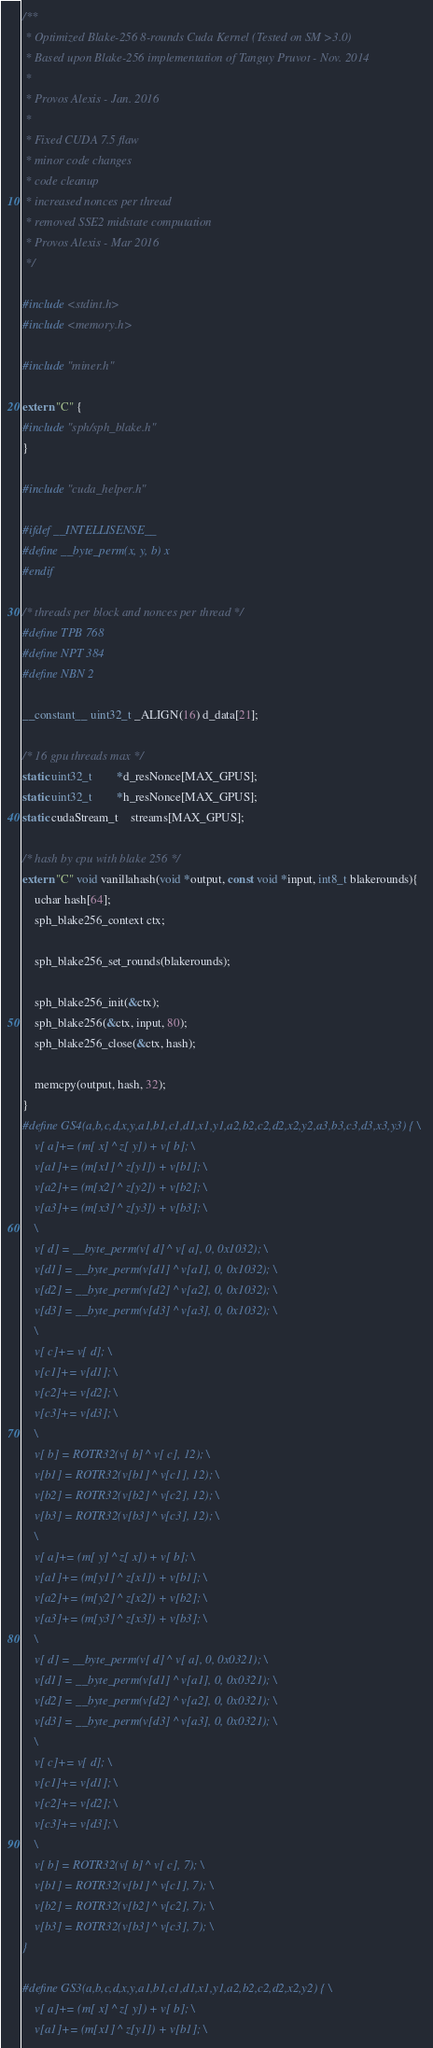Convert code to text. <code><loc_0><loc_0><loc_500><loc_500><_Cuda_>/**
 * Optimized Blake-256 8-rounds Cuda Kernel (Tested on SM >3.0)
 * Based upon Blake-256 implementation of Tanguy Pruvot - Nov. 2014
 *
 * Provos Alexis - Jan. 2016
 *
 * Fixed CUDA 7.5 flaw
 * minor code changes
 * code cleanup
 * increased nonces per thread
 * removed SSE2 midstate computation
 * Provos Alexis - Mar 2016
 */

#include <stdint.h>
#include <memory.h>

#include "miner.h"

extern "C" {
#include "sph/sph_blake.h"
}

#include "cuda_helper.h"

#ifdef __INTELLISENSE__
#define __byte_perm(x, y, b) x
#endif

/* threads per block and nonces per thread */
#define TPB 768
#define NPT 384
#define NBN 2

__constant__ uint32_t _ALIGN(16) d_data[21];

/* 16 gpu threads max */
static uint32_t		*d_resNonce[MAX_GPUS];
static uint32_t		*h_resNonce[MAX_GPUS];
static cudaStream_t	streams[MAX_GPUS];

/* hash by cpu with blake 256 */
extern "C" void vanillahash(void *output, const void *input, int8_t blakerounds){
	uchar hash[64];
	sph_blake256_context ctx;

	sph_blake256_set_rounds(blakerounds);

	sph_blake256_init(&ctx);
	sph_blake256(&ctx, input, 80);
	sph_blake256_close(&ctx, hash);

	memcpy(output, hash, 32);
}
#define GS4(a,b,c,d,x,y,a1,b1,c1,d1,x1,y1,a2,b2,c2,d2,x2,y2,a3,b3,c3,d3,x3,y3) { \
	v[ a]+= (m[ x] ^ z[ y]) + v[ b]; \
	v[a1]+= (m[x1] ^ z[y1]) + v[b1]; \
	v[a2]+= (m[x2] ^ z[y2]) + v[b2]; \
	v[a3]+= (m[x3] ^ z[y3]) + v[b3]; \
	\
	v[ d] = __byte_perm(v[ d] ^ v[ a], 0, 0x1032); \
	v[d1] = __byte_perm(v[d1] ^ v[a1], 0, 0x1032); \
	v[d2] = __byte_perm(v[d2] ^ v[a2], 0, 0x1032); \
	v[d3] = __byte_perm(v[d3] ^ v[a3], 0, 0x1032); \
	\
	v[ c]+= v[ d]; \
	v[c1]+= v[d1]; \
	v[c2]+= v[d2]; \
	v[c3]+= v[d3]; \
	\
	v[ b] = ROTR32(v[ b] ^ v[ c], 12); \
	v[b1] = ROTR32(v[b1] ^ v[c1], 12); \
	v[b2] = ROTR32(v[b2] ^ v[c2], 12); \
	v[b3] = ROTR32(v[b3] ^ v[c3], 12); \
	\
	v[ a]+= (m[ y] ^ z[ x]) + v[ b]; \
	v[a1]+= (m[y1] ^ z[x1]) + v[b1]; \
	v[a2]+= (m[y2] ^ z[x2]) + v[b2]; \
	v[a3]+= (m[y3] ^ z[x3]) + v[b3]; \
	\
	v[ d] = __byte_perm(v[ d] ^ v[ a], 0, 0x0321); \
	v[d1] = __byte_perm(v[d1] ^ v[a1], 0, 0x0321); \
	v[d2] = __byte_perm(v[d2] ^ v[a2], 0, 0x0321); \
	v[d3] = __byte_perm(v[d3] ^ v[a3], 0, 0x0321); \
	\
	v[ c]+= v[ d]; \
	v[c1]+= v[d1]; \
	v[c2]+= v[d2]; \
	v[c3]+= v[d3]; \
	\
	v[ b] = ROTR32(v[ b] ^ v[ c], 7); \
	v[b1] = ROTR32(v[b1] ^ v[c1], 7); \
	v[b2] = ROTR32(v[b2] ^ v[c2], 7); \
	v[b3] = ROTR32(v[b3] ^ v[c3], 7); \
}

#define GS3(a,b,c,d,x,y,a1,b1,c1,d1,x1,y1,a2,b2,c2,d2,x2,y2) { \
	v[ a]+= (m[ x] ^ z[ y]) + v[ b]; \
	v[a1]+= (m[x1] ^ z[y1]) + v[b1]; \</code> 